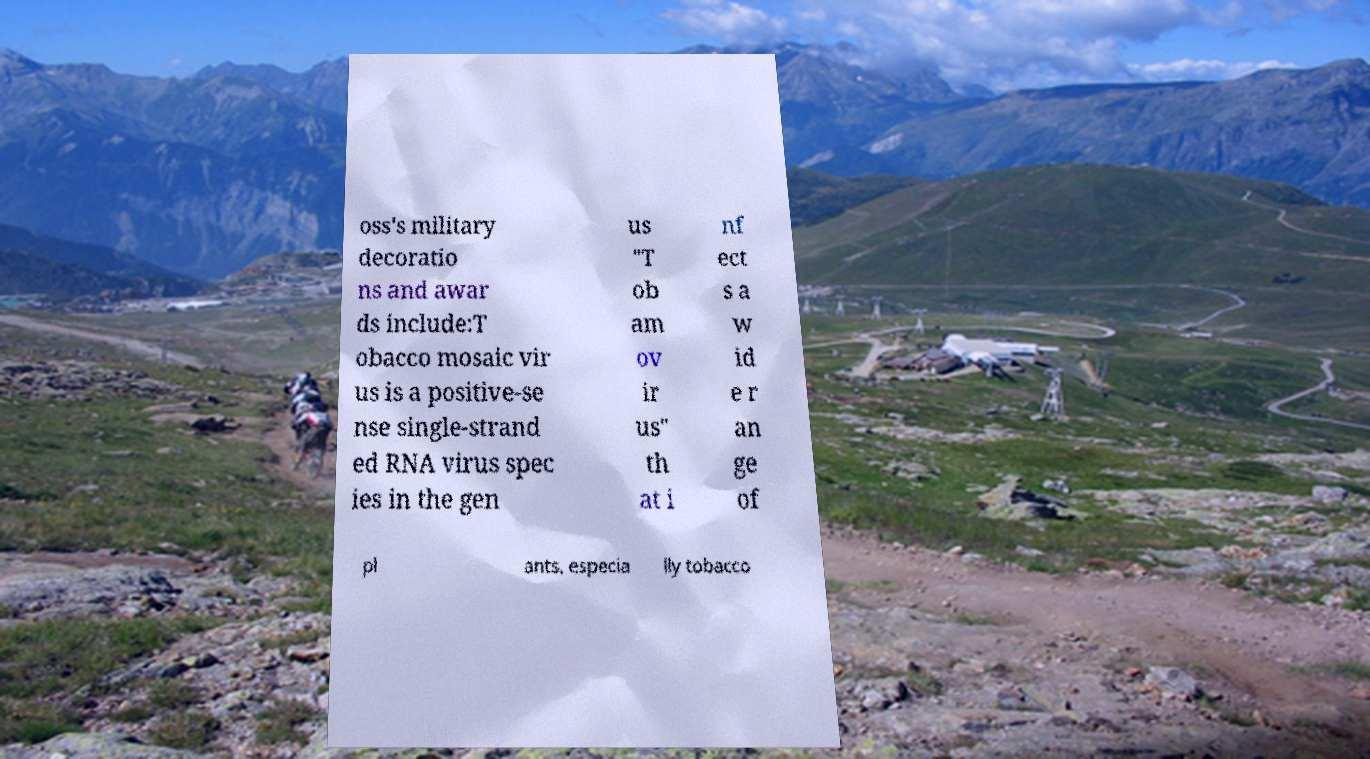Could you assist in decoding the text presented in this image and type it out clearly? oss's military decoratio ns and awar ds include:T obacco mosaic vir us is a positive-se nse single-strand ed RNA virus spec ies in the gen us "T ob am ov ir us" th at i nf ect s a w id e r an ge of pl ants, especia lly tobacco 